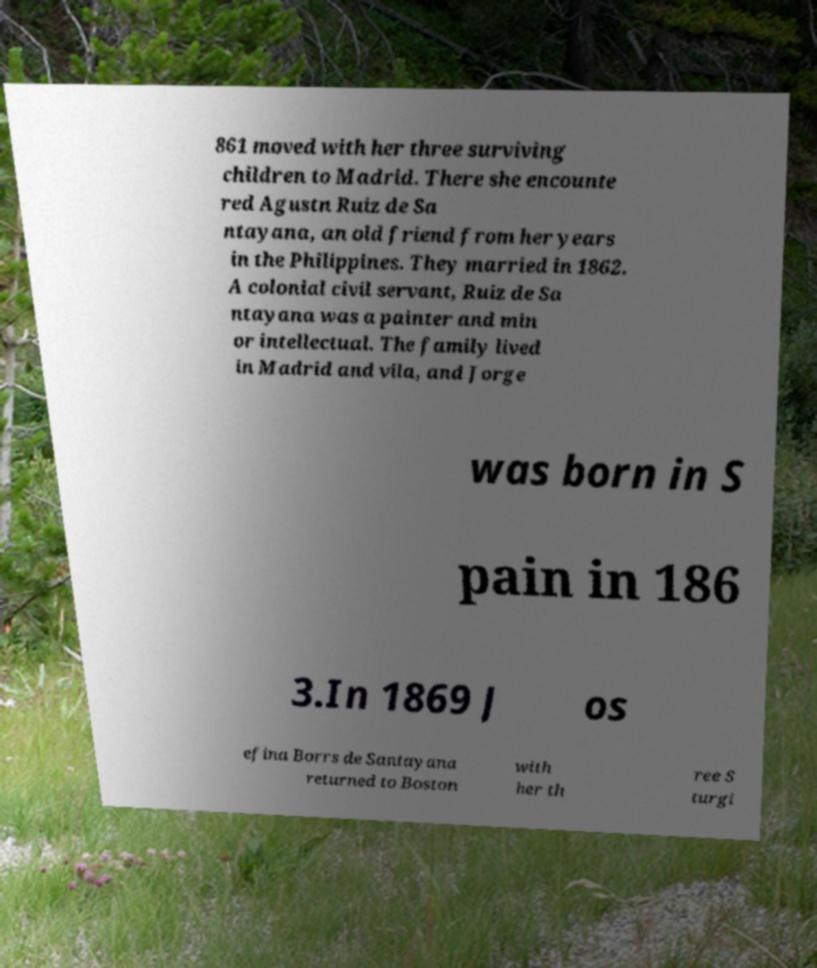Could you extract and type out the text from this image? 861 moved with her three surviving children to Madrid. There she encounte red Agustn Ruiz de Sa ntayana, an old friend from her years in the Philippines. They married in 1862. A colonial civil servant, Ruiz de Sa ntayana was a painter and min or intellectual. The family lived in Madrid and vila, and Jorge was born in S pain in 186 3.In 1869 J os efina Borrs de Santayana returned to Boston with her th ree S turgi 